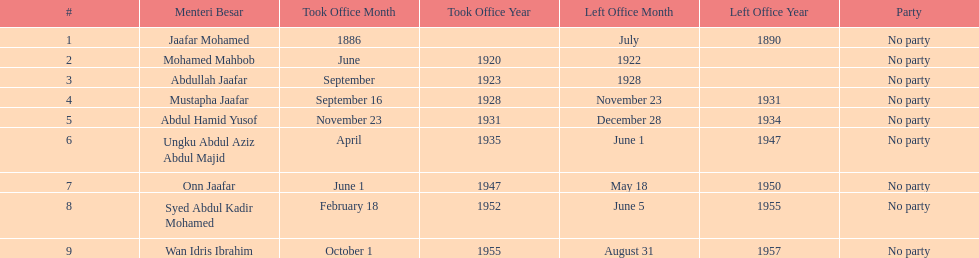Name someone who was not in office more than 4 years. Mohamed Mahbob. 